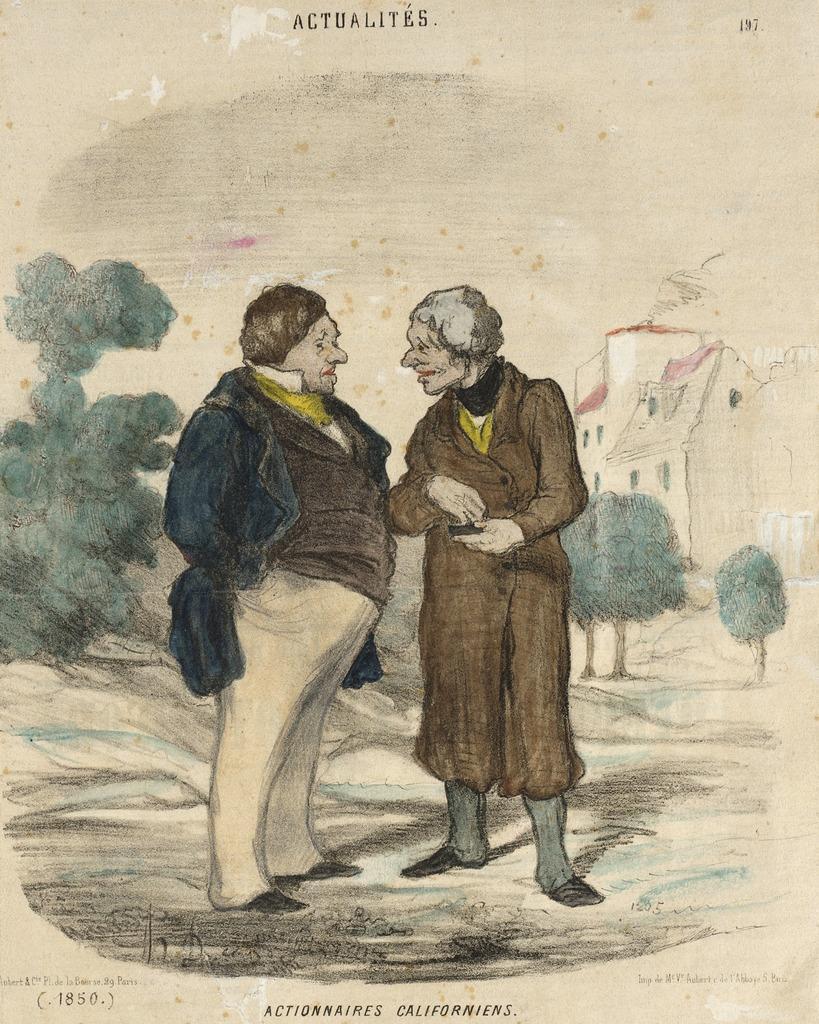Can you describe this image briefly? In the picture I can see the painting. In the painting I can see two persons standing on the ground. I can see a house and trees in the painting. 